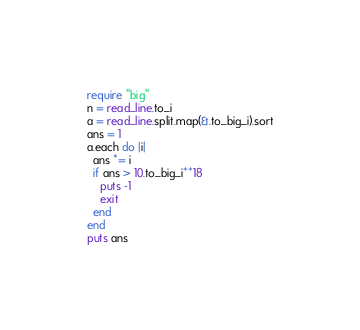Convert code to text. <code><loc_0><loc_0><loc_500><loc_500><_Crystal_>require "big"
n = read_line.to_i
a = read_line.split.map(&.to_big_i).sort
ans = 1
a.each do |i|
  ans *= i
  if ans > 10.to_big_i**18
    puts -1
    exit
  end
end
puts ans
</code> 